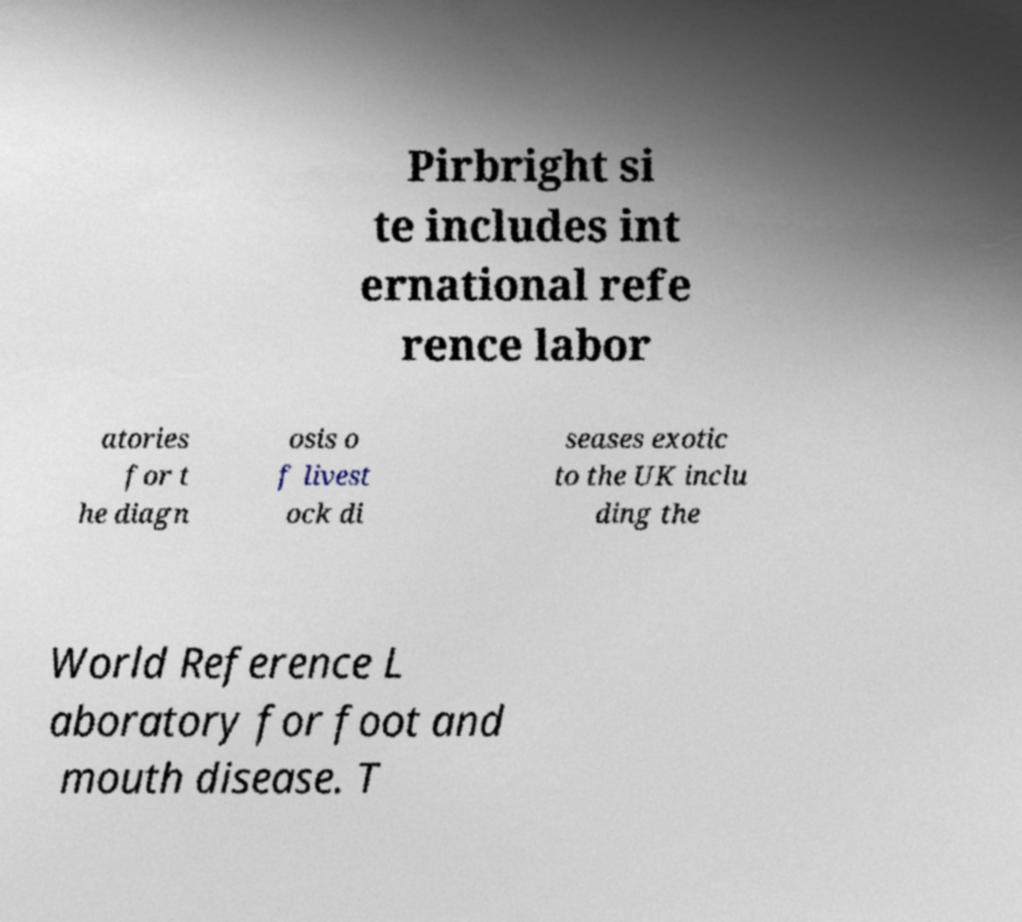Please identify and transcribe the text found in this image. Pirbright si te includes int ernational refe rence labor atories for t he diagn osis o f livest ock di seases exotic to the UK inclu ding the World Reference L aboratory for foot and mouth disease. T 